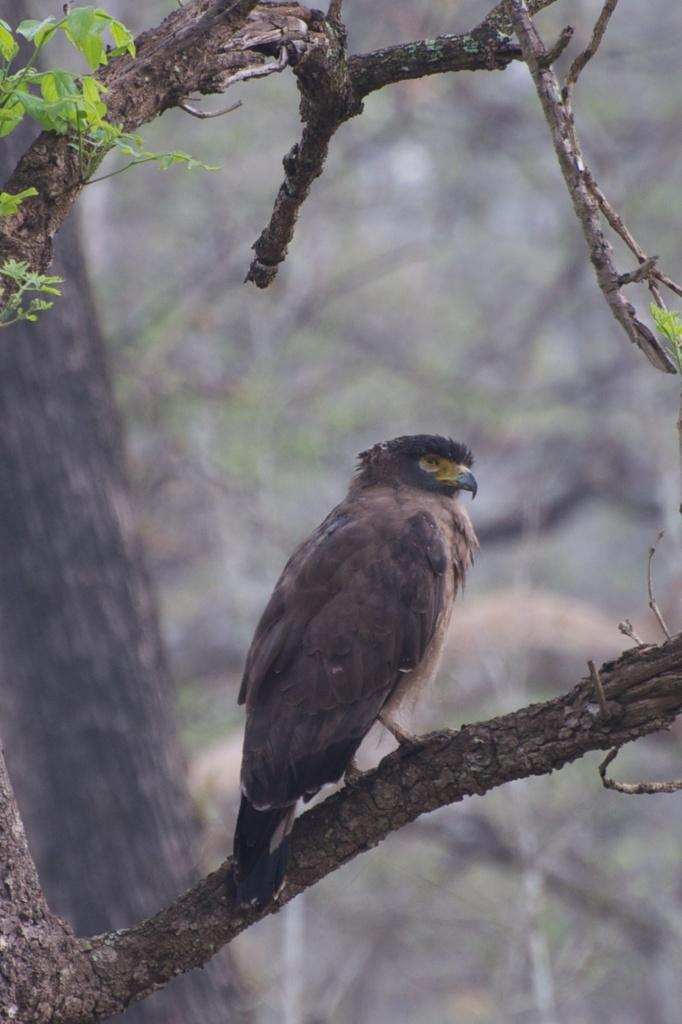What type of animal can be seen in the image? There is a bird in the image. Where is the bird located? The bird is on a branch in the image. What part of the tree is visible in the image? There is a tree trunk in the image. What type of vegetation is present in the image? There are leaves in the image. How would you describe the background of the image? The background of the image is blurry. How many chairs are visible in the image? There are no chairs present in the image. What type of cream is being used by the bird in the image? There is no cream or any food item being used by the bird in the image; it is simply perched on a branch. 